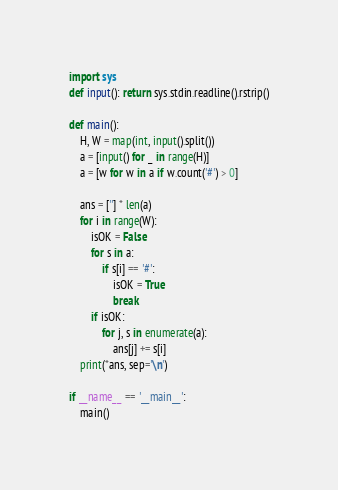<code> <loc_0><loc_0><loc_500><loc_500><_Python_>import sys
def input(): return sys.stdin.readline().rstrip()

def main():
    H, W = map(int, input().split())
    a = [input() for _ in range(H)]
    a = [w for w in a if w.count('#') > 0]

    ans = [''] * len(a)
    for i in range(W):
        isOK = False
        for s in a:
            if s[i] == '#':
                isOK = True
                break
        if isOK:
            for j, s in enumerate(a):
                ans[j] += s[i]
    print(*ans, sep='\n')

if __name__ == '__main__':
    main()
</code> 